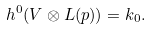<formula> <loc_0><loc_0><loc_500><loc_500>h ^ { 0 } ( V \otimes L ( p ) ) = k _ { 0 } .</formula> 